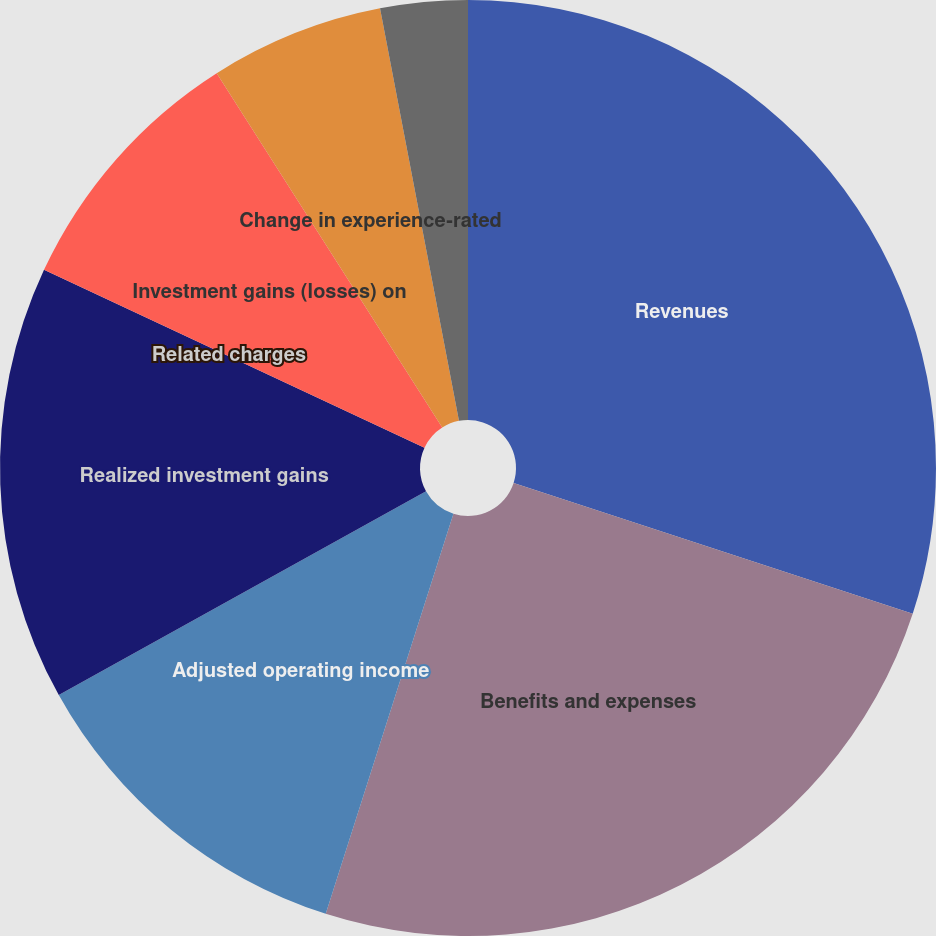Convert chart to OTSL. <chart><loc_0><loc_0><loc_500><loc_500><pie_chart><fcel>Revenues<fcel>Benefits and expenses<fcel>Adjusted operating income<fcel>Realized investment gains<fcel>Related charges<fcel>Investment gains (losses) on<fcel>Change in experience-rated<fcel>Income (loss) from continuing<nl><fcel>30.04%<fcel>24.87%<fcel>12.02%<fcel>15.02%<fcel>0.0%<fcel>9.02%<fcel>6.01%<fcel>3.01%<nl></chart> 